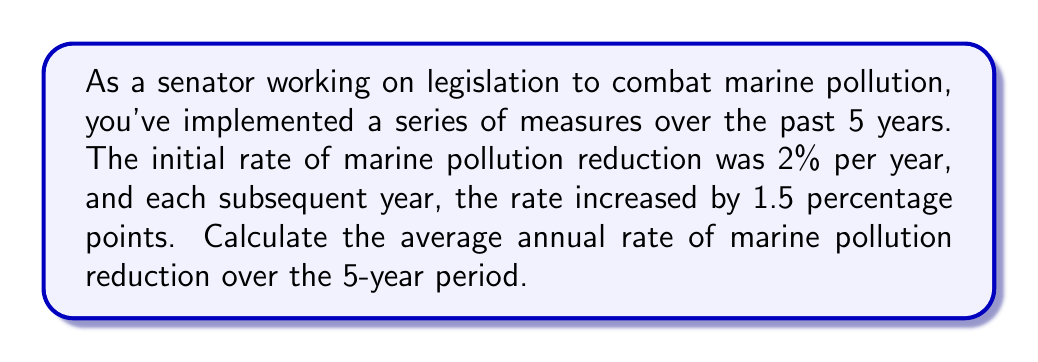Give your solution to this math problem. To solve this problem, we need to follow these steps:

1. Identify the reduction rates for each year:
   Year 1: 2%
   Year 2: 2% + 1.5% = 3.5%
   Year 3: 3.5% + 1.5% = 5%
   Year 4: 5% + 1.5% = 6.5%
   Year 5: 6.5% + 1.5% = 8%

2. Calculate the sum of these rates:
   $$S = 2\% + 3.5\% + 5\% + 6.5\% + 8\% = 25\%$$

3. Calculate the average rate by dividing the sum by the number of years:
   $$\text{Average Rate} = \frac{S}{n} = \frac{25\%}{5} = 5\%$$

Alternatively, we can use the arithmetic sequence formula:
$$S_n = \frac{n}{2}(a_1 + a_n)$$

Where:
$S_n$ is the sum of the series
$n$ is the number of terms (5 years)
$a_1$ is the first term (2%)
$a_n$ is the last term (8%)

$$S_5 = \frac{5}{2}(2\% + 8\%) = \frac{5}{2}(10\%) = 25\%$$

Then, we divide by the number of years to get the average:
$$\text{Average Rate} = \frac{25\%}{5} = 5\%$$

This approach yields the same result as the step-by-step method.
Answer: The average annual rate of marine pollution reduction over the 5-year period is 5%. 